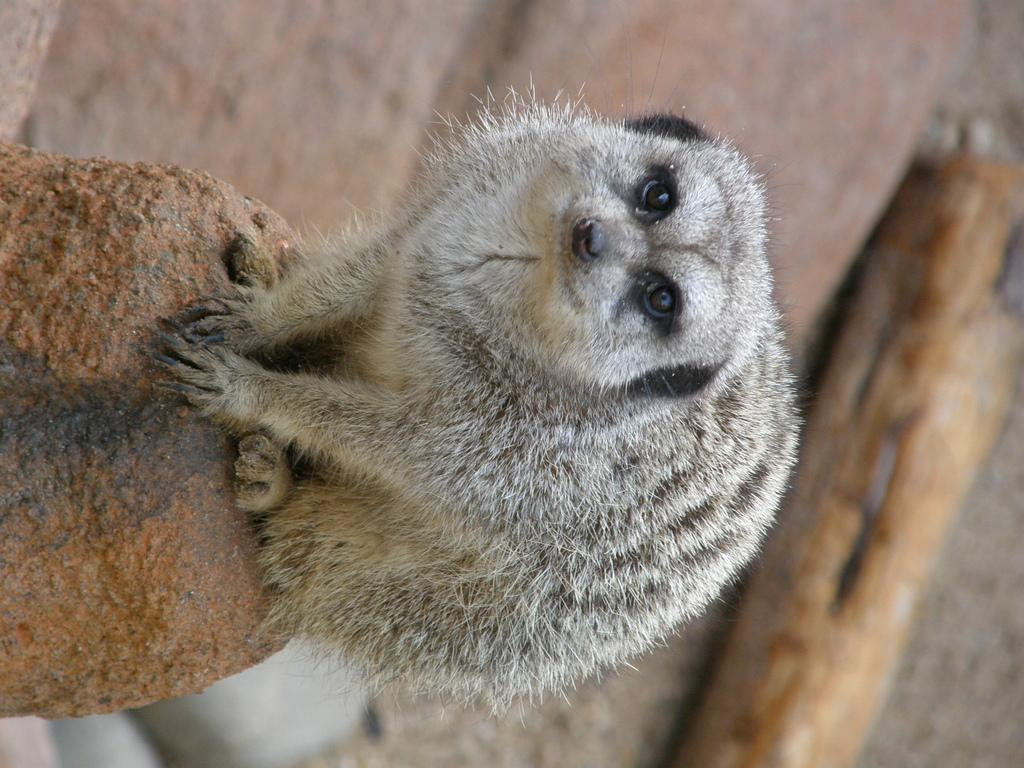What animal is in the image? There is a meerkat in the image. Where is the meerkat located? The meerkat is on a path. Can you describe the background of the image? The background of the image is blurred. How does the meerkat express its feelings in the image? The image does not show the meerkat expressing any feelings, as it is a still image and does not capture emotions. 